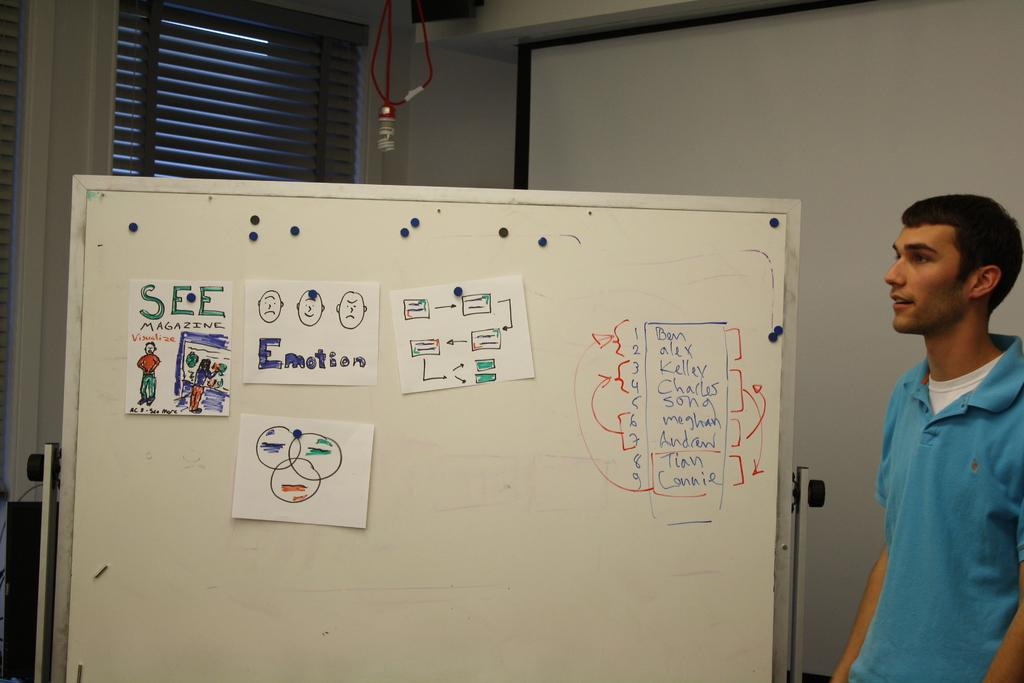Provide a one-sentence caption for the provided image. Man giving an explanation with a picture of "Emotion" on the board. 